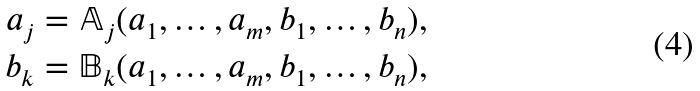Convert formula to latex. <formula><loc_0><loc_0><loc_500><loc_500>a _ { j } & = \mathbb { A } _ { j } ( a _ { 1 } , \dots , a _ { m } , b _ { 1 } , \dots , b _ { n } ) , \\ b _ { k } & = \mathbb { B } _ { k } ( a _ { 1 } , \dots , a _ { m } , b _ { 1 } , \dots , b _ { n } ) ,</formula> 